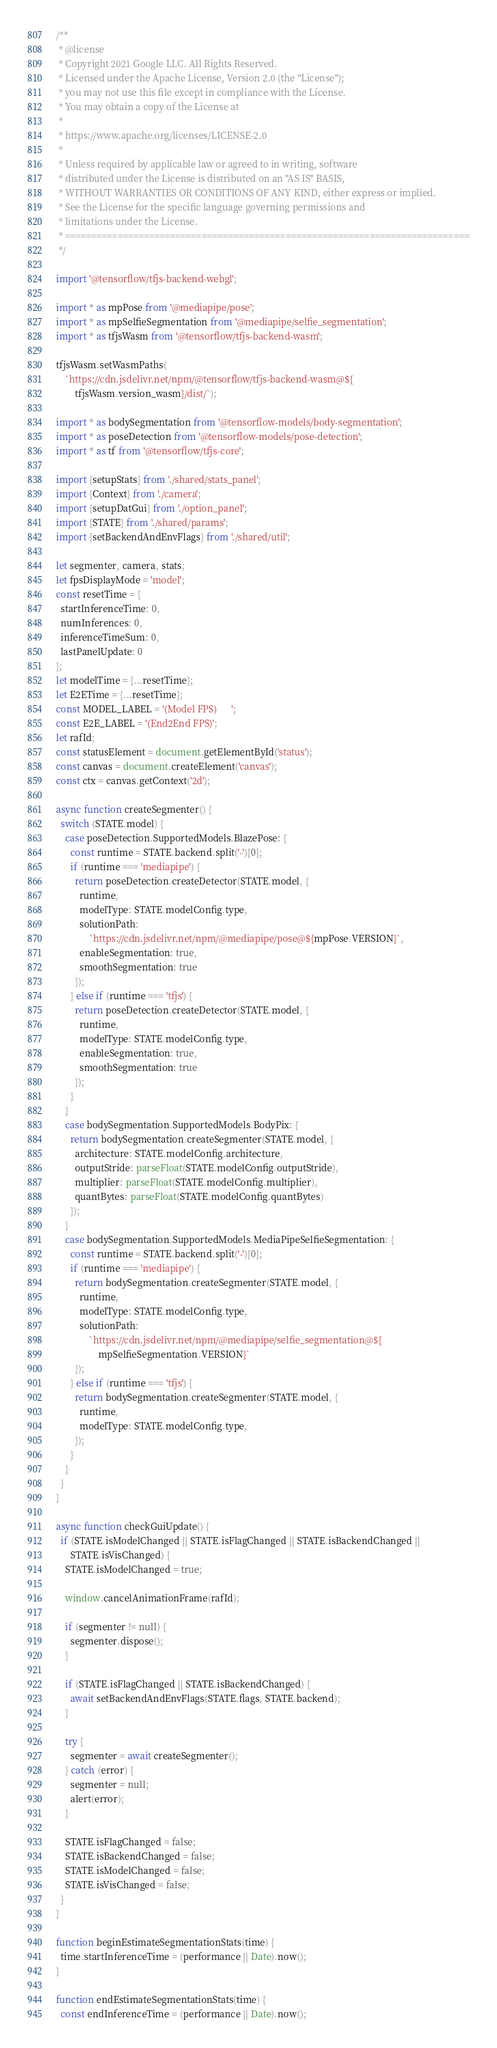Convert code to text. <code><loc_0><loc_0><loc_500><loc_500><_JavaScript_>/**
 * @license
 * Copyright 2021 Google LLC. All Rights Reserved.
 * Licensed under the Apache License, Version 2.0 (the "License");
 * you may not use this file except in compliance with the License.
 * You may obtain a copy of the License at
 *
 * https://www.apache.org/licenses/LICENSE-2.0
 *
 * Unless required by applicable law or agreed to in writing, software
 * distributed under the License is distributed on an "AS IS" BASIS,
 * WITHOUT WARRANTIES OR CONDITIONS OF ANY KIND, either express or implied.
 * See the License for the specific language governing permissions and
 * limitations under the License.
 * =============================================================================
 */

import '@tensorflow/tfjs-backend-webgl';

import * as mpPose from '@mediapipe/pose';
import * as mpSelfieSegmentation from '@mediapipe/selfie_segmentation';
import * as tfjsWasm from '@tensorflow/tfjs-backend-wasm';

tfjsWasm.setWasmPaths(
    `https://cdn.jsdelivr.net/npm/@tensorflow/tfjs-backend-wasm@${
        tfjsWasm.version_wasm}/dist/`);

import * as bodySegmentation from '@tensorflow-models/body-segmentation';
import * as poseDetection from '@tensorflow-models/pose-detection';
import * as tf from '@tensorflow/tfjs-core';

import {setupStats} from './shared/stats_panel';
import {Context} from './camera';
import {setupDatGui} from './option_panel';
import {STATE} from './shared/params';
import {setBackendAndEnvFlags} from './shared/util';

let segmenter, camera, stats;
let fpsDisplayMode = 'model';
const resetTime = {
  startInferenceTime: 0,
  numInferences: 0,
  inferenceTimeSum: 0,
  lastPanelUpdate: 0
};
let modelTime = {...resetTime};
let E2ETime = {...resetTime};
const MODEL_LABEL = '(Model FPS)      ';
const E2E_LABEL = '(End2End FPS)';
let rafId;
const statusElement = document.getElementById('status');
const canvas = document.createElement('canvas');
const ctx = canvas.getContext('2d');

async function createSegmenter() {
  switch (STATE.model) {
    case poseDetection.SupportedModels.BlazePose: {
      const runtime = STATE.backend.split('-')[0];
      if (runtime === 'mediapipe') {
        return poseDetection.createDetector(STATE.model, {
          runtime,
          modelType: STATE.modelConfig.type,
          solutionPath:
              `https://cdn.jsdelivr.net/npm/@mediapipe/pose@${mpPose.VERSION}`,
          enableSegmentation: true,
          smoothSegmentation: true
        });
      } else if (runtime === 'tfjs') {
        return poseDetection.createDetector(STATE.model, {
          runtime,
          modelType: STATE.modelConfig.type,
          enableSegmentation: true,
          smoothSegmentation: true
        });
      }
    }
    case bodySegmentation.SupportedModels.BodyPix: {
      return bodySegmentation.createSegmenter(STATE.model, {
        architecture: STATE.modelConfig.architecture,
        outputStride: parseFloat(STATE.modelConfig.outputStride),
        multiplier: parseFloat(STATE.modelConfig.multiplier),
        quantBytes: parseFloat(STATE.modelConfig.quantBytes)
      });
    }
    case bodySegmentation.SupportedModels.MediaPipeSelfieSegmentation: {
      const runtime = STATE.backend.split('-')[0];
      if (runtime === 'mediapipe') {
        return bodySegmentation.createSegmenter(STATE.model, {
          runtime,
          modelType: STATE.modelConfig.type,
          solutionPath:
              `https://cdn.jsdelivr.net/npm/@mediapipe/selfie_segmentation@${
                  mpSelfieSegmentation.VERSION}`
        });
      } else if (runtime === 'tfjs') {
        return bodySegmentation.createSegmenter(STATE.model, {
          runtime,
          modelType: STATE.modelConfig.type,
        });
      }
    }
  }
}

async function checkGuiUpdate() {
  if (STATE.isModelChanged || STATE.isFlagChanged || STATE.isBackendChanged ||
      STATE.isVisChanged) {
    STATE.isModelChanged = true;

    window.cancelAnimationFrame(rafId);

    if (segmenter != null) {
      segmenter.dispose();
    }

    if (STATE.isFlagChanged || STATE.isBackendChanged) {
      await setBackendAndEnvFlags(STATE.flags, STATE.backend);
    }

    try {
      segmenter = await createSegmenter();
    } catch (error) {
      segmenter = null;
      alert(error);
    }

    STATE.isFlagChanged = false;
    STATE.isBackendChanged = false;
    STATE.isModelChanged = false;
    STATE.isVisChanged = false;
  }
}

function beginEstimateSegmentationStats(time) {
  time.startInferenceTime = (performance || Date).now();
}

function endEstimateSegmentationStats(time) {
  const endInferenceTime = (performance || Date).now();</code> 